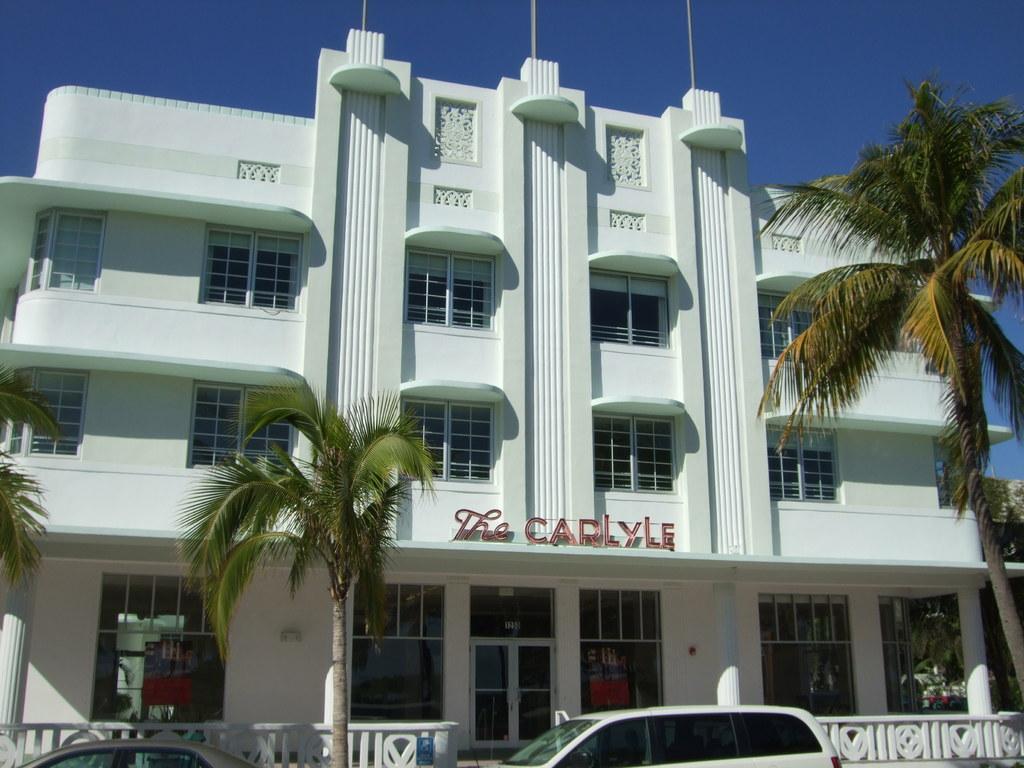Could you give a brief overview of what you see in this image? In this image there are few vehicles. Behind it there is a fence. There are few trees. Behind there is a building. Top of the image there is sky. On the building there is some text. 